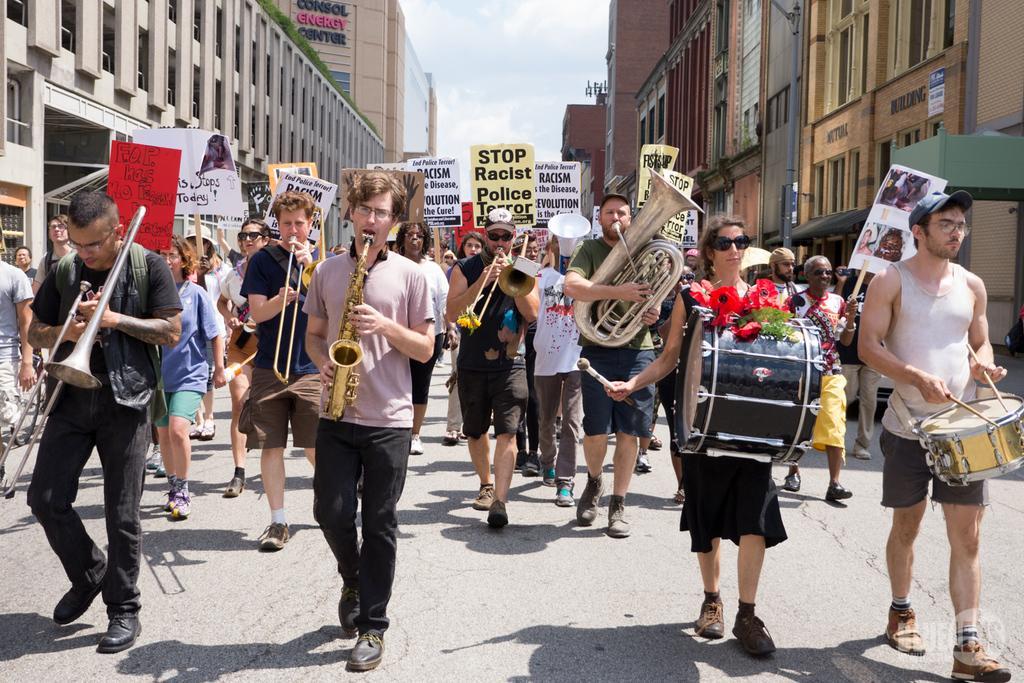Can you describe this image briefly? As we can see in the image there is a sky, banner, buildings and few people walking on road and playing different types of musical instruments. 